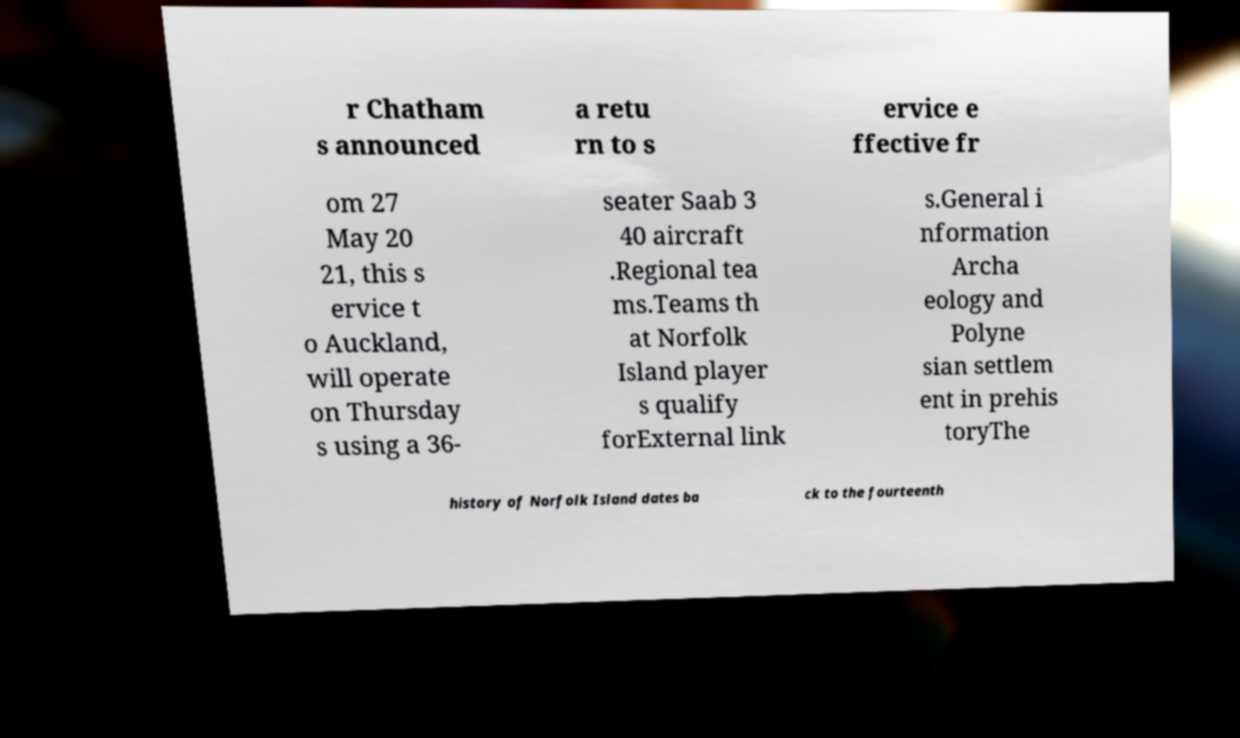Could you extract and type out the text from this image? r Chatham s announced a retu rn to s ervice e ffective fr om 27 May 20 21, this s ervice t o Auckland, will operate on Thursday s using a 36- seater Saab 3 40 aircraft .Regional tea ms.Teams th at Norfolk Island player s qualify forExternal link s.General i nformation Archa eology and Polyne sian settlem ent in prehis toryThe history of Norfolk Island dates ba ck to the fourteenth 